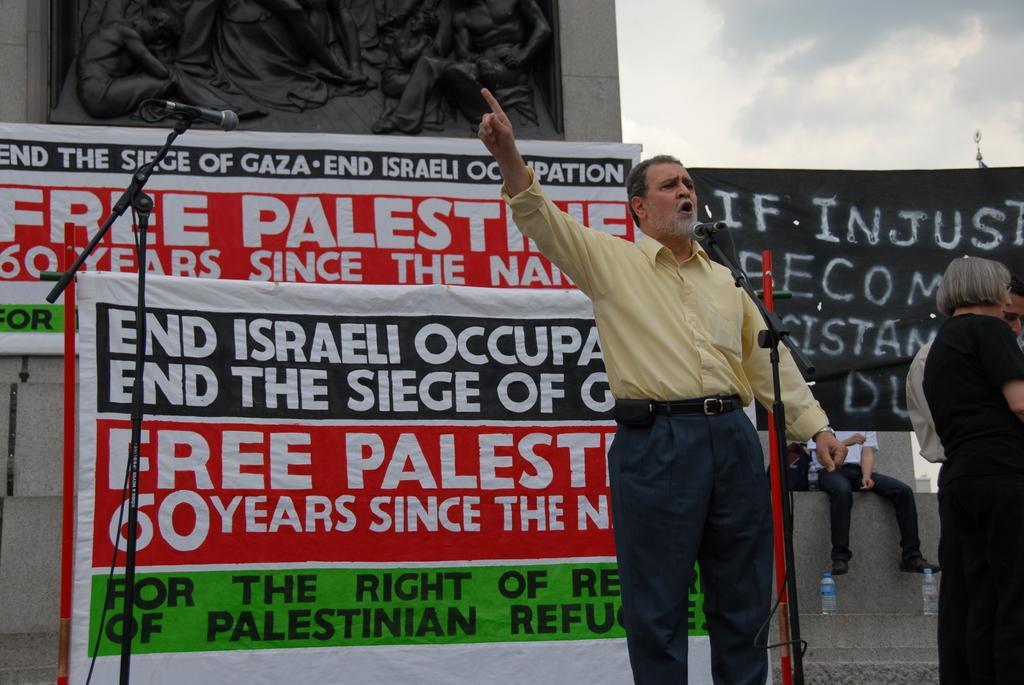Please provide a concise description of this image. There are people standing and this man talking and we can see microphones with stands. Background we can see banners ,bottles and there is a person sitting. 